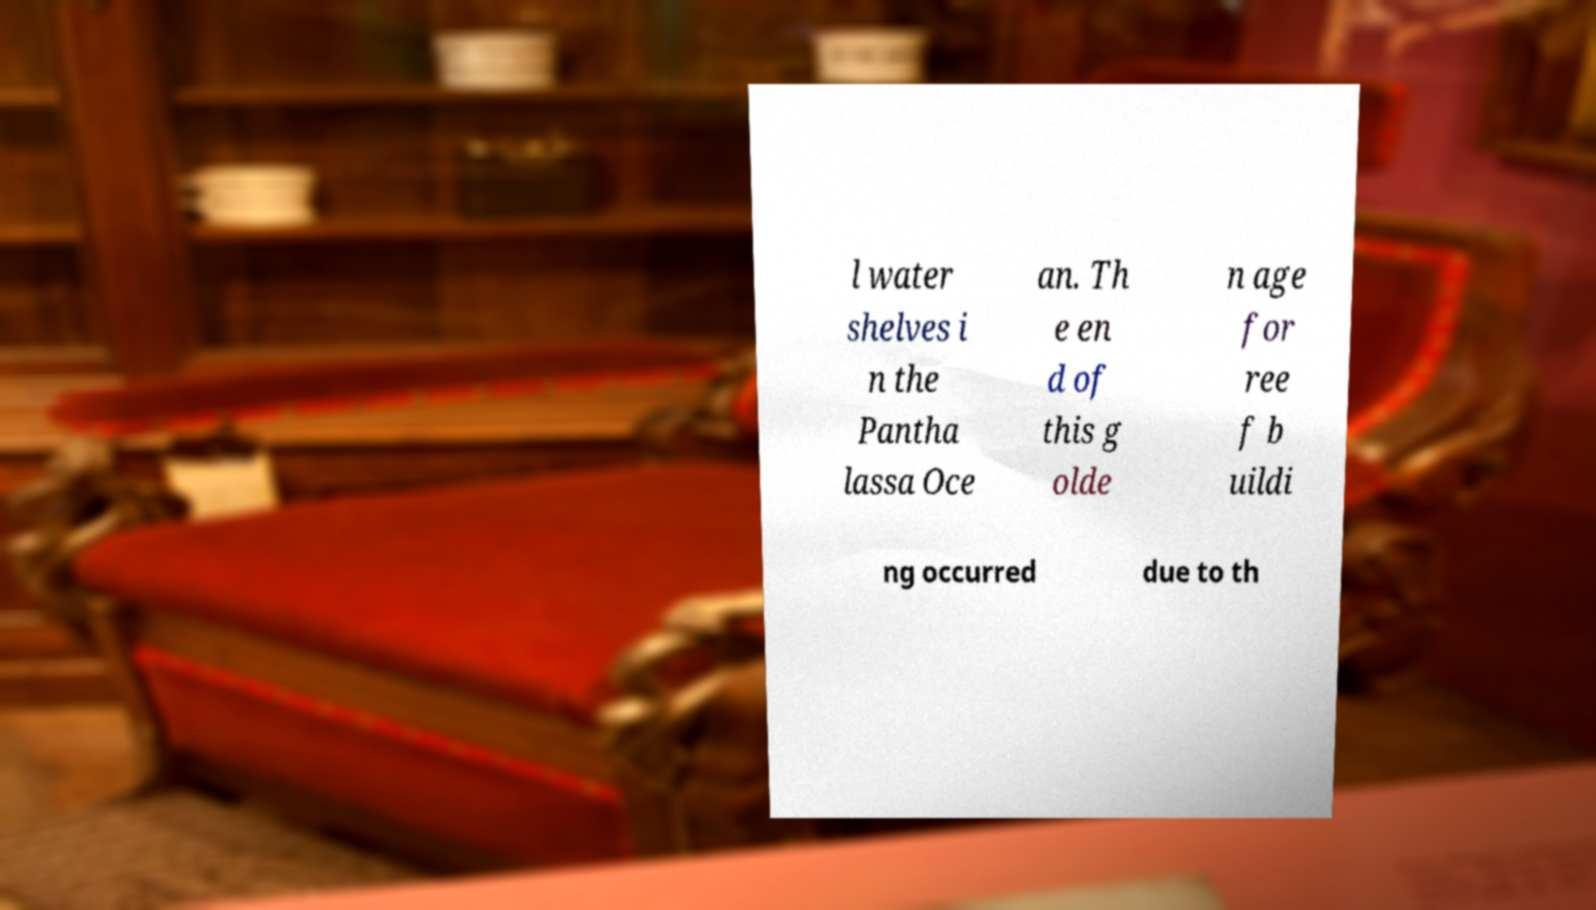Can you accurately transcribe the text from the provided image for me? l water shelves i n the Pantha lassa Oce an. Th e en d of this g olde n age for ree f b uildi ng occurred due to th 